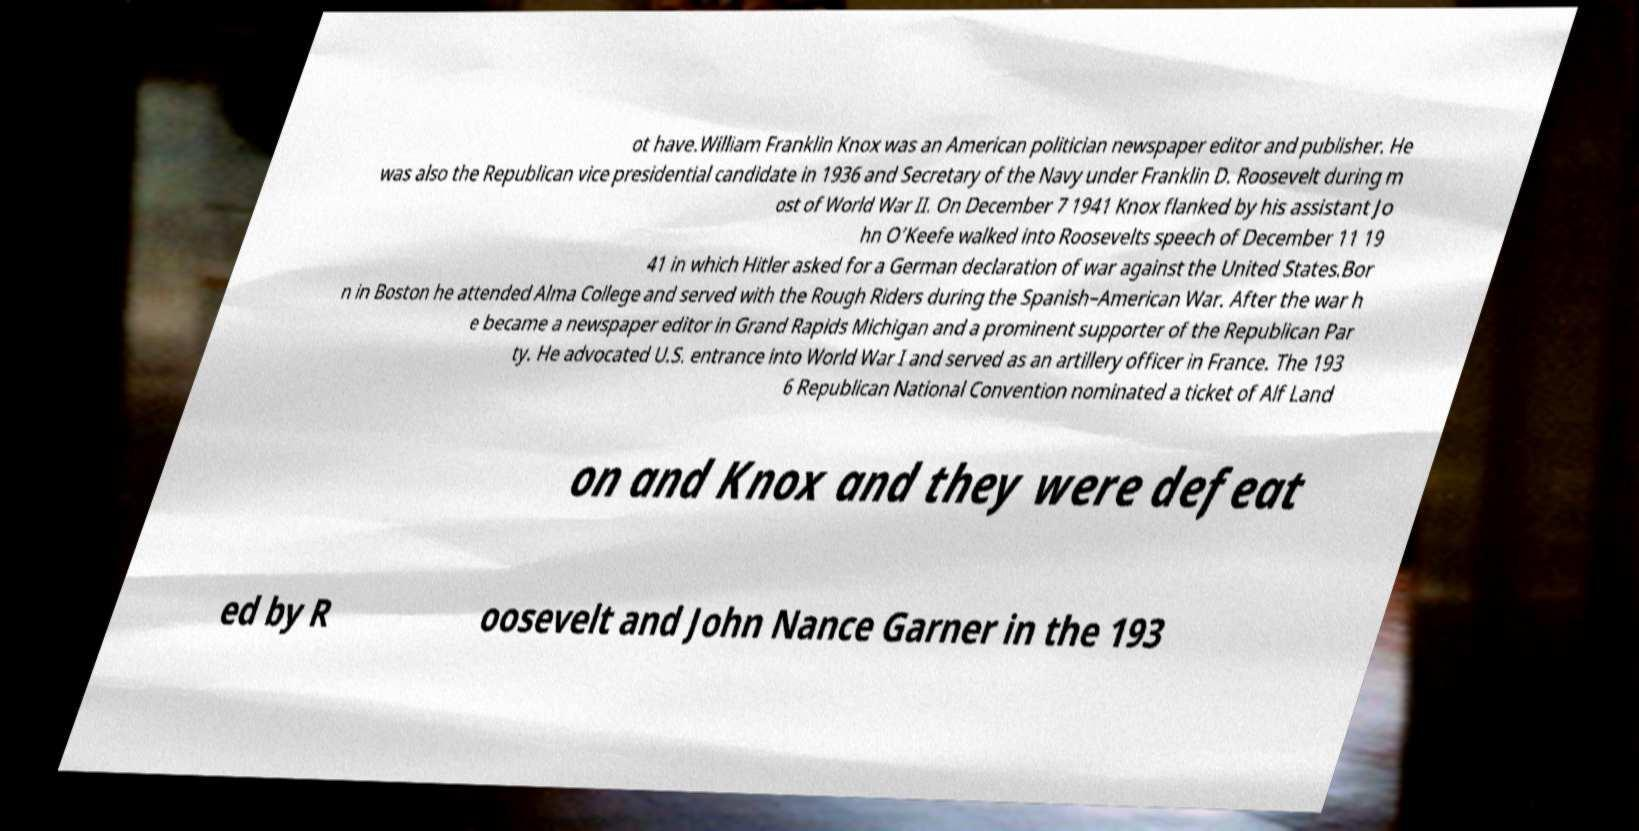There's text embedded in this image that I need extracted. Can you transcribe it verbatim? ot have.William Franklin Knox was an American politician newspaper editor and publisher. He was also the Republican vice presidential candidate in 1936 and Secretary of the Navy under Franklin D. Roosevelt during m ost of World War II. On December 7 1941 Knox flanked by his assistant Jo hn O’Keefe walked into Roosevelts speech of December 11 19 41 in which Hitler asked for a German declaration of war against the United States.Bor n in Boston he attended Alma College and served with the Rough Riders during the Spanish–American War. After the war h e became a newspaper editor in Grand Rapids Michigan and a prominent supporter of the Republican Par ty. He advocated U.S. entrance into World War I and served as an artillery officer in France. The 193 6 Republican National Convention nominated a ticket of Alf Land on and Knox and they were defeat ed by R oosevelt and John Nance Garner in the 193 